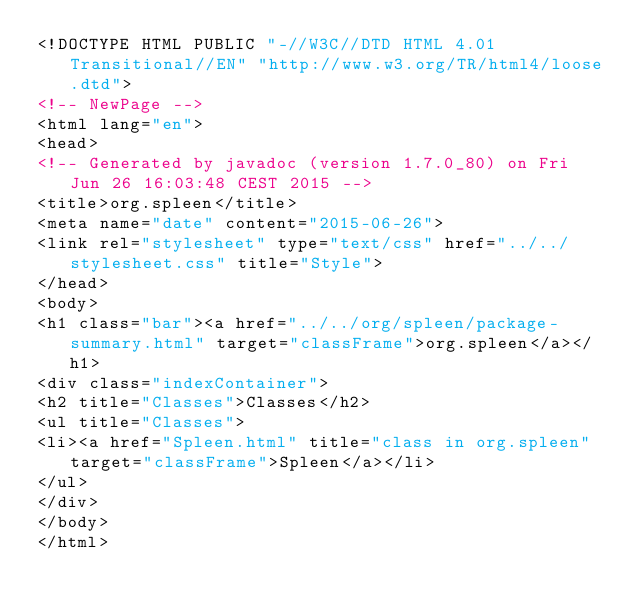Convert code to text. <code><loc_0><loc_0><loc_500><loc_500><_HTML_><!DOCTYPE HTML PUBLIC "-//W3C//DTD HTML 4.01 Transitional//EN" "http://www.w3.org/TR/html4/loose.dtd">
<!-- NewPage -->
<html lang="en">
<head>
<!-- Generated by javadoc (version 1.7.0_80) on Fri Jun 26 16:03:48 CEST 2015 -->
<title>org.spleen</title>
<meta name="date" content="2015-06-26">
<link rel="stylesheet" type="text/css" href="../../stylesheet.css" title="Style">
</head>
<body>
<h1 class="bar"><a href="../../org/spleen/package-summary.html" target="classFrame">org.spleen</a></h1>
<div class="indexContainer">
<h2 title="Classes">Classes</h2>
<ul title="Classes">
<li><a href="Spleen.html" title="class in org.spleen" target="classFrame">Spleen</a></li>
</ul>
</div>
</body>
</html>
</code> 